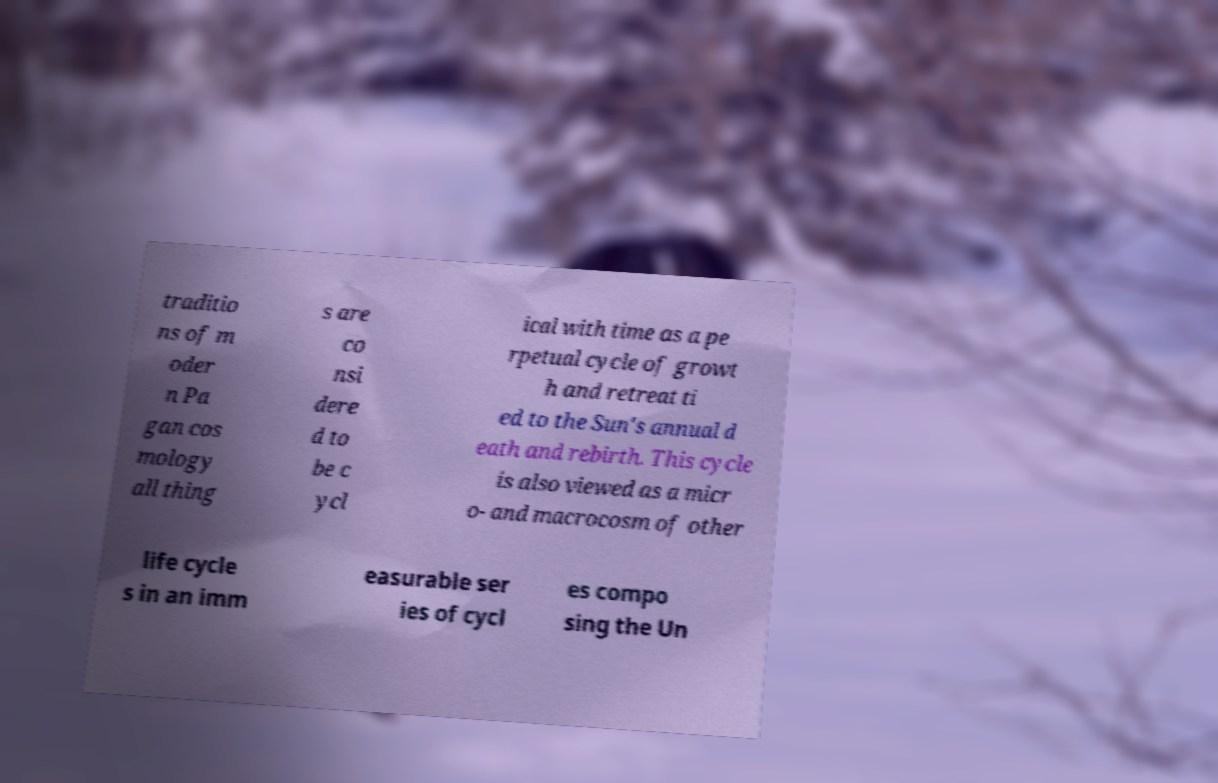There's text embedded in this image that I need extracted. Can you transcribe it verbatim? traditio ns of m oder n Pa gan cos mology all thing s are co nsi dere d to be c ycl ical with time as a pe rpetual cycle of growt h and retreat ti ed to the Sun's annual d eath and rebirth. This cycle is also viewed as a micr o- and macrocosm of other life cycle s in an imm easurable ser ies of cycl es compo sing the Un 